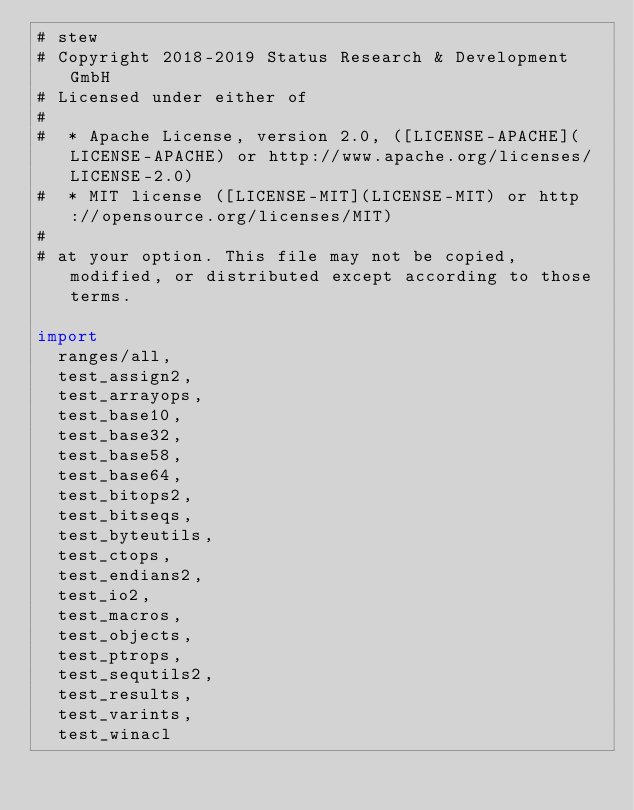<code> <loc_0><loc_0><loc_500><loc_500><_Nim_># stew
# Copyright 2018-2019 Status Research & Development GmbH
# Licensed under either of
#
#  * Apache License, version 2.0, ([LICENSE-APACHE](LICENSE-APACHE) or http://www.apache.org/licenses/LICENSE-2.0)
#  * MIT license ([LICENSE-MIT](LICENSE-MIT) or http://opensource.org/licenses/MIT)
#
# at your option. This file may not be copied, modified, or distributed except according to those terms.

import
  ranges/all,
  test_assign2,
  test_arrayops,
  test_base10,
  test_base32,
  test_base58,
  test_base64,
  test_bitops2,
  test_bitseqs,
  test_byteutils,
  test_ctops,
  test_endians2,
  test_io2,
  test_macros,
  test_objects,
  test_ptrops,
  test_sequtils2,
  test_results,
  test_varints,
  test_winacl
</code> 